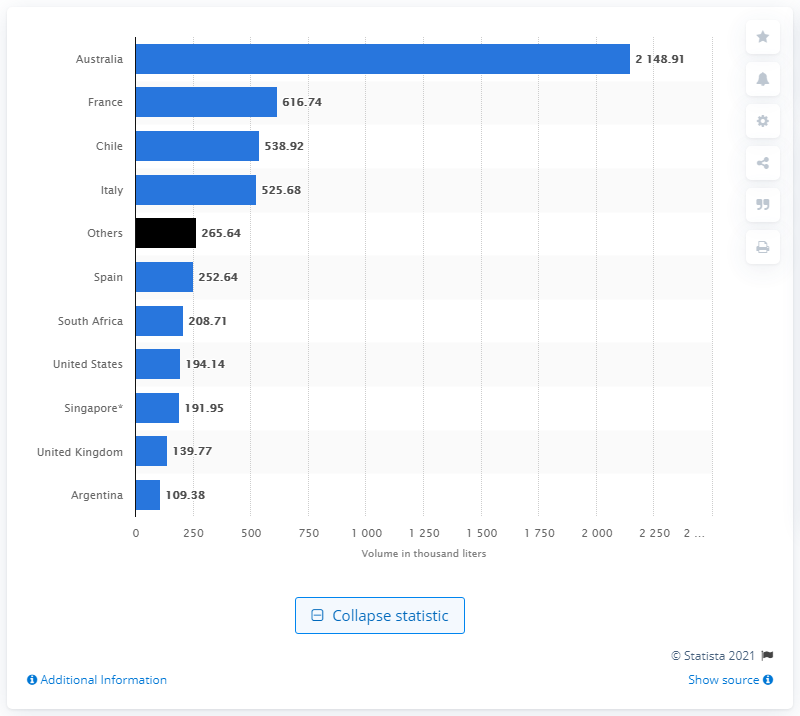Give some essential details in this illustration. In 2018, Chile was the third largest wine exporter to India. In 2019, India imported more than two million liters of wine from Australia. 